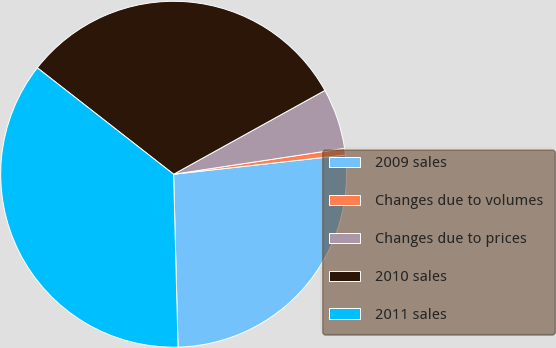Convert chart. <chart><loc_0><loc_0><loc_500><loc_500><pie_chart><fcel>2009 sales<fcel>Changes due to volumes<fcel>Changes due to prices<fcel>2010 sales<fcel>2011 sales<nl><fcel>26.37%<fcel>0.62%<fcel>5.66%<fcel>31.4%<fcel>35.96%<nl></chart> 